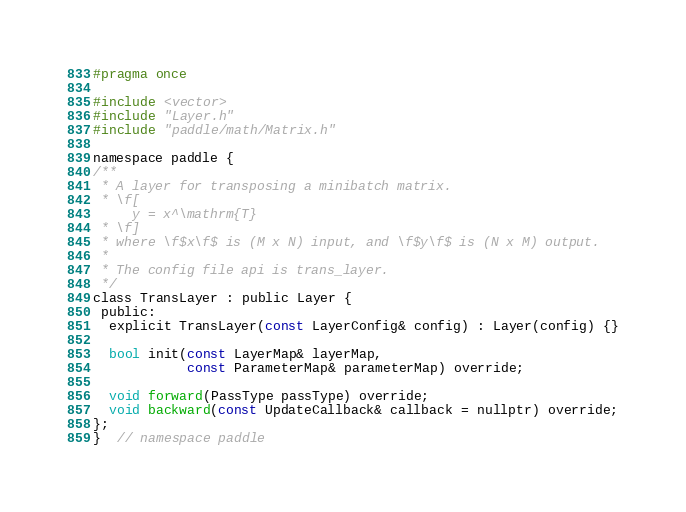<code> <loc_0><loc_0><loc_500><loc_500><_C_>#pragma once

#include <vector>
#include "Layer.h"
#include "paddle/math/Matrix.h"

namespace paddle {
/**
 * A layer for transposing a minibatch matrix.
 * \f[
     y = x^\mathrm{T}
 * \f]
 * where \f$x\f$ is (M x N) input, and \f$y\f$ is (N x M) output.
 *
 * The config file api is trans_layer.
 */
class TransLayer : public Layer {
 public:
  explicit TransLayer(const LayerConfig& config) : Layer(config) {}

  bool init(const LayerMap& layerMap,
            const ParameterMap& parameterMap) override;

  void forward(PassType passType) override;
  void backward(const UpdateCallback& callback = nullptr) override;
};
}  // namespace paddle
</code> 